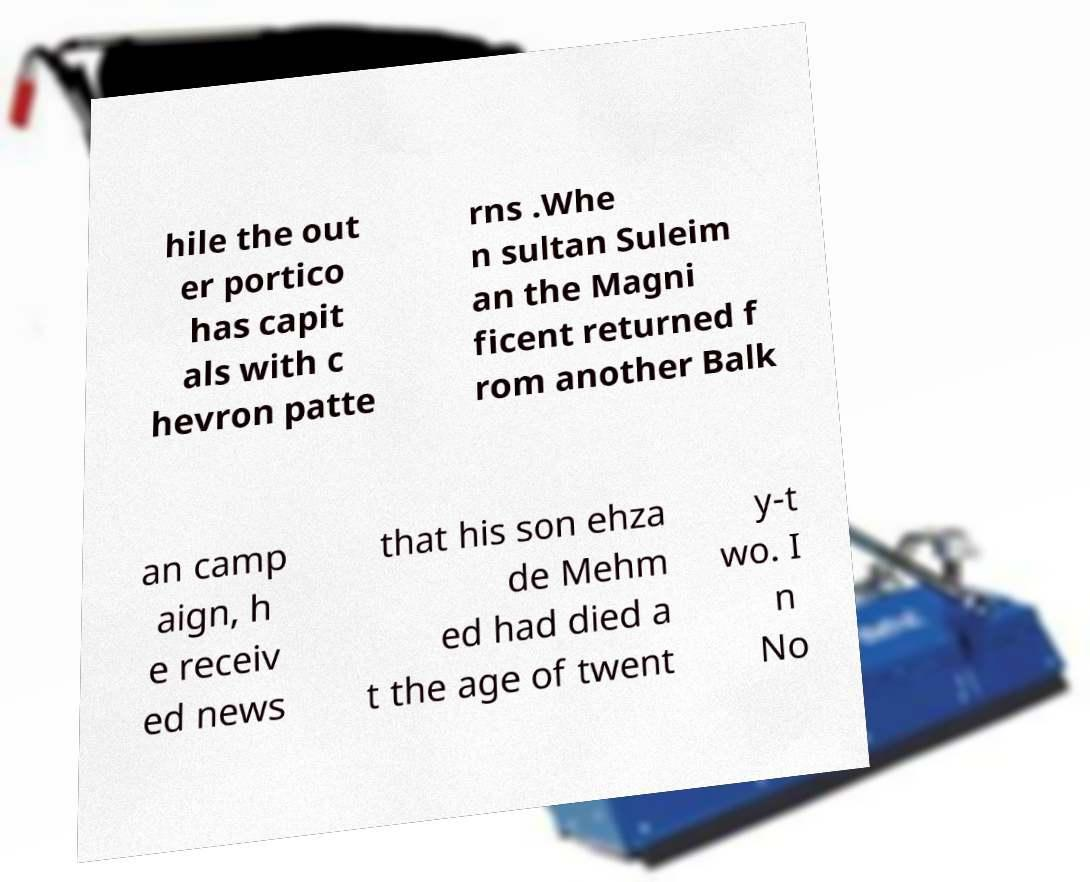Please identify and transcribe the text found in this image. hile the out er portico has capit als with c hevron patte rns .Whe n sultan Suleim an the Magni ficent returned f rom another Balk an camp aign, h e receiv ed news that his son ehza de Mehm ed had died a t the age of twent y-t wo. I n No 